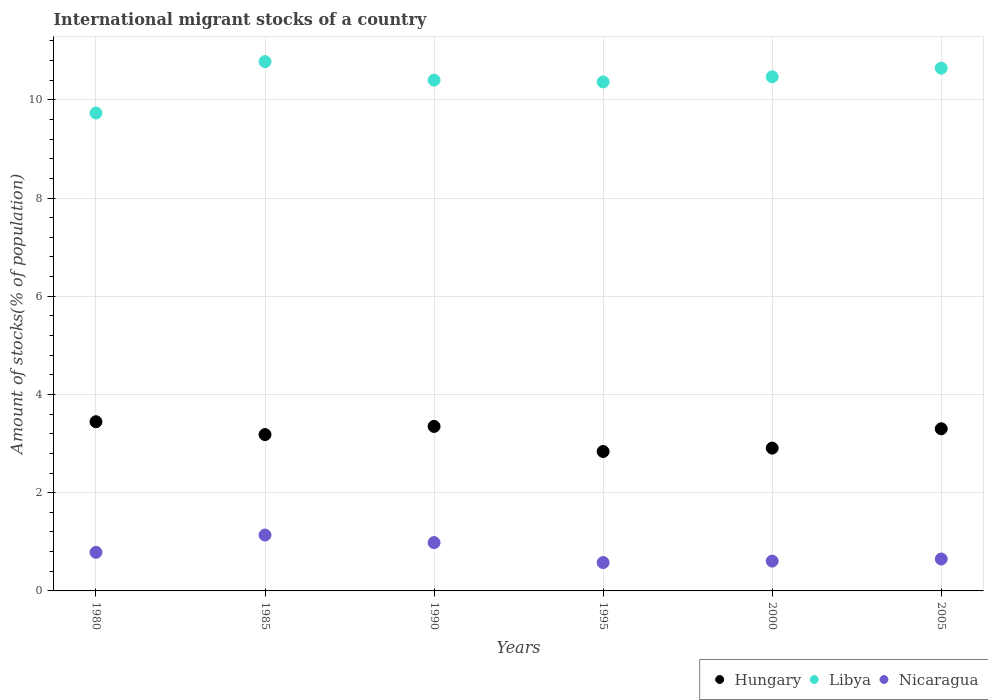How many different coloured dotlines are there?
Your answer should be very brief. 3. What is the amount of stocks in in Hungary in 1985?
Provide a succinct answer. 3.18. Across all years, what is the maximum amount of stocks in in Nicaragua?
Offer a very short reply. 1.14. Across all years, what is the minimum amount of stocks in in Nicaragua?
Your response must be concise. 0.58. In which year was the amount of stocks in in Hungary minimum?
Your answer should be compact. 1995. What is the total amount of stocks in in Libya in the graph?
Make the answer very short. 62.39. What is the difference between the amount of stocks in in Nicaragua in 1980 and that in 1990?
Your answer should be compact. -0.2. What is the difference between the amount of stocks in in Hungary in 1995 and the amount of stocks in in Libya in 2000?
Your answer should be compact. -7.63. What is the average amount of stocks in in Hungary per year?
Ensure brevity in your answer.  3.17. In the year 1990, what is the difference between the amount of stocks in in Libya and amount of stocks in in Nicaragua?
Provide a short and direct response. 9.42. What is the ratio of the amount of stocks in in Libya in 1980 to that in 1995?
Provide a succinct answer. 0.94. Is the amount of stocks in in Nicaragua in 1985 less than that in 2000?
Your answer should be very brief. No. What is the difference between the highest and the second highest amount of stocks in in Nicaragua?
Provide a short and direct response. 0.15. What is the difference between the highest and the lowest amount of stocks in in Libya?
Ensure brevity in your answer.  1.05. In how many years, is the amount of stocks in in Libya greater than the average amount of stocks in in Libya taken over all years?
Your answer should be compact. 4. Is the sum of the amount of stocks in in Hungary in 1990 and 1995 greater than the maximum amount of stocks in in Libya across all years?
Your answer should be very brief. No. Is the amount of stocks in in Nicaragua strictly greater than the amount of stocks in in Hungary over the years?
Provide a succinct answer. No. Is the amount of stocks in in Hungary strictly less than the amount of stocks in in Libya over the years?
Your answer should be compact. Yes. How many dotlines are there?
Make the answer very short. 3. How many years are there in the graph?
Your answer should be very brief. 6. What is the difference between two consecutive major ticks on the Y-axis?
Make the answer very short. 2. Are the values on the major ticks of Y-axis written in scientific E-notation?
Your answer should be compact. No. Does the graph contain grids?
Ensure brevity in your answer.  Yes. Where does the legend appear in the graph?
Your response must be concise. Bottom right. How are the legend labels stacked?
Offer a very short reply. Horizontal. What is the title of the graph?
Give a very brief answer. International migrant stocks of a country. Does "Brazil" appear as one of the legend labels in the graph?
Your answer should be very brief. No. What is the label or title of the Y-axis?
Your response must be concise. Amount of stocks(% of population). What is the Amount of stocks(% of population) of Hungary in 1980?
Give a very brief answer. 3.45. What is the Amount of stocks(% of population) of Libya in 1980?
Your response must be concise. 9.73. What is the Amount of stocks(% of population) in Nicaragua in 1980?
Provide a succinct answer. 0.79. What is the Amount of stocks(% of population) of Hungary in 1985?
Your answer should be very brief. 3.18. What is the Amount of stocks(% of population) of Libya in 1985?
Offer a very short reply. 10.78. What is the Amount of stocks(% of population) in Nicaragua in 1985?
Offer a terse response. 1.14. What is the Amount of stocks(% of population) of Hungary in 1990?
Keep it short and to the point. 3.35. What is the Amount of stocks(% of population) of Libya in 1990?
Offer a very short reply. 10.4. What is the Amount of stocks(% of population) in Nicaragua in 1990?
Your answer should be compact. 0.98. What is the Amount of stocks(% of population) in Hungary in 1995?
Give a very brief answer. 2.84. What is the Amount of stocks(% of population) of Libya in 1995?
Keep it short and to the point. 10.36. What is the Amount of stocks(% of population) of Nicaragua in 1995?
Your response must be concise. 0.58. What is the Amount of stocks(% of population) of Hungary in 2000?
Ensure brevity in your answer.  2.91. What is the Amount of stocks(% of population) in Libya in 2000?
Give a very brief answer. 10.47. What is the Amount of stocks(% of population) of Nicaragua in 2000?
Offer a very short reply. 0.61. What is the Amount of stocks(% of population) in Hungary in 2005?
Offer a terse response. 3.3. What is the Amount of stocks(% of population) of Libya in 2005?
Make the answer very short. 10.64. What is the Amount of stocks(% of population) of Nicaragua in 2005?
Provide a succinct answer. 0.65. Across all years, what is the maximum Amount of stocks(% of population) of Hungary?
Provide a succinct answer. 3.45. Across all years, what is the maximum Amount of stocks(% of population) of Libya?
Give a very brief answer. 10.78. Across all years, what is the maximum Amount of stocks(% of population) in Nicaragua?
Your response must be concise. 1.14. Across all years, what is the minimum Amount of stocks(% of population) of Hungary?
Your answer should be compact. 2.84. Across all years, what is the minimum Amount of stocks(% of population) of Libya?
Give a very brief answer. 9.73. Across all years, what is the minimum Amount of stocks(% of population) in Nicaragua?
Your response must be concise. 0.58. What is the total Amount of stocks(% of population) of Hungary in the graph?
Offer a very short reply. 19.03. What is the total Amount of stocks(% of population) of Libya in the graph?
Provide a succinct answer. 62.39. What is the total Amount of stocks(% of population) in Nicaragua in the graph?
Provide a short and direct response. 4.74. What is the difference between the Amount of stocks(% of population) of Hungary in 1980 and that in 1985?
Offer a terse response. 0.26. What is the difference between the Amount of stocks(% of population) of Libya in 1980 and that in 1985?
Offer a terse response. -1.05. What is the difference between the Amount of stocks(% of population) of Nicaragua in 1980 and that in 1985?
Make the answer very short. -0.35. What is the difference between the Amount of stocks(% of population) in Hungary in 1980 and that in 1990?
Your answer should be compact. 0.1. What is the difference between the Amount of stocks(% of population) in Libya in 1980 and that in 1990?
Your answer should be very brief. -0.67. What is the difference between the Amount of stocks(% of population) in Nicaragua in 1980 and that in 1990?
Keep it short and to the point. -0.2. What is the difference between the Amount of stocks(% of population) in Hungary in 1980 and that in 1995?
Keep it short and to the point. 0.61. What is the difference between the Amount of stocks(% of population) in Libya in 1980 and that in 1995?
Keep it short and to the point. -0.63. What is the difference between the Amount of stocks(% of population) of Nicaragua in 1980 and that in 1995?
Provide a short and direct response. 0.21. What is the difference between the Amount of stocks(% of population) in Hungary in 1980 and that in 2000?
Provide a succinct answer. 0.54. What is the difference between the Amount of stocks(% of population) in Libya in 1980 and that in 2000?
Give a very brief answer. -0.74. What is the difference between the Amount of stocks(% of population) in Nicaragua in 1980 and that in 2000?
Give a very brief answer. 0.18. What is the difference between the Amount of stocks(% of population) of Hungary in 1980 and that in 2005?
Offer a terse response. 0.14. What is the difference between the Amount of stocks(% of population) in Libya in 1980 and that in 2005?
Your answer should be compact. -0.91. What is the difference between the Amount of stocks(% of population) in Nicaragua in 1980 and that in 2005?
Your answer should be very brief. 0.14. What is the difference between the Amount of stocks(% of population) in Hungary in 1985 and that in 1990?
Provide a short and direct response. -0.17. What is the difference between the Amount of stocks(% of population) of Libya in 1985 and that in 1990?
Your answer should be compact. 0.38. What is the difference between the Amount of stocks(% of population) in Nicaragua in 1985 and that in 1990?
Your answer should be compact. 0.15. What is the difference between the Amount of stocks(% of population) in Hungary in 1985 and that in 1995?
Make the answer very short. 0.34. What is the difference between the Amount of stocks(% of population) in Libya in 1985 and that in 1995?
Ensure brevity in your answer.  0.41. What is the difference between the Amount of stocks(% of population) of Nicaragua in 1985 and that in 1995?
Your answer should be very brief. 0.56. What is the difference between the Amount of stocks(% of population) of Hungary in 1985 and that in 2000?
Provide a short and direct response. 0.28. What is the difference between the Amount of stocks(% of population) in Libya in 1985 and that in 2000?
Give a very brief answer. 0.31. What is the difference between the Amount of stocks(% of population) in Nicaragua in 1985 and that in 2000?
Provide a succinct answer. 0.53. What is the difference between the Amount of stocks(% of population) of Hungary in 1985 and that in 2005?
Provide a short and direct response. -0.12. What is the difference between the Amount of stocks(% of population) of Libya in 1985 and that in 2005?
Ensure brevity in your answer.  0.13. What is the difference between the Amount of stocks(% of population) in Nicaragua in 1985 and that in 2005?
Your response must be concise. 0.49. What is the difference between the Amount of stocks(% of population) in Hungary in 1990 and that in 1995?
Give a very brief answer. 0.51. What is the difference between the Amount of stocks(% of population) of Libya in 1990 and that in 1995?
Offer a very short reply. 0.04. What is the difference between the Amount of stocks(% of population) of Nicaragua in 1990 and that in 1995?
Offer a terse response. 0.41. What is the difference between the Amount of stocks(% of population) of Hungary in 1990 and that in 2000?
Provide a short and direct response. 0.44. What is the difference between the Amount of stocks(% of population) of Libya in 1990 and that in 2000?
Your answer should be compact. -0.07. What is the difference between the Amount of stocks(% of population) of Nicaragua in 1990 and that in 2000?
Make the answer very short. 0.38. What is the difference between the Amount of stocks(% of population) in Hungary in 1990 and that in 2005?
Your response must be concise. 0.05. What is the difference between the Amount of stocks(% of population) of Libya in 1990 and that in 2005?
Provide a succinct answer. -0.24. What is the difference between the Amount of stocks(% of population) in Nicaragua in 1990 and that in 2005?
Offer a very short reply. 0.33. What is the difference between the Amount of stocks(% of population) of Hungary in 1995 and that in 2000?
Ensure brevity in your answer.  -0.07. What is the difference between the Amount of stocks(% of population) in Libya in 1995 and that in 2000?
Offer a terse response. -0.1. What is the difference between the Amount of stocks(% of population) in Nicaragua in 1995 and that in 2000?
Your answer should be compact. -0.03. What is the difference between the Amount of stocks(% of population) of Hungary in 1995 and that in 2005?
Your response must be concise. -0.46. What is the difference between the Amount of stocks(% of population) in Libya in 1995 and that in 2005?
Offer a very short reply. -0.28. What is the difference between the Amount of stocks(% of population) in Nicaragua in 1995 and that in 2005?
Your answer should be compact. -0.07. What is the difference between the Amount of stocks(% of population) in Hungary in 2000 and that in 2005?
Your answer should be compact. -0.39. What is the difference between the Amount of stocks(% of population) in Libya in 2000 and that in 2005?
Your response must be concise. -0.18. What is the difference between the Amount of stocks(% of population) in Nicaragua in 2000 and that in 2005?
Make the answer very short. -0.04. What is the difference between the Amount of stocks(% of population) in Hungary in 1980 and the Amount of stocks(% of population) in Libya in 1985?
Your response must be concise. -7.33. What is the difference between the Amount of stocks(% of population) in Hungary in 1980 and the Amount of stocks(% of population) in Nicaragua in 1985?
Provide a succinct answer. 2.31. What is the difference between the Amount of stocks(% of population) of Libya in 1980 and the Amount of stocks(% of population) of Nicaragua in 1985?
Your answer should be compact. 8.59. What is the difference between the Amount of stocks(% of population) of Hungary in 1980 and the Amount of stocks(% of population) of Libya in 1990?
Ensure brevity in your answer.  -6.96. What is the difference between the Amount of stocks(% of population) in Hungary in 1980 and the Amount of stocks(% of population) in Nicaragua in 1990?
Your answer should be very brief. 2.46. What is the difference between the Amount of stocks(% of population) of Libya in 1980 and the Amount of stocks(% of population) of Nicaragua in 1990?
Ensure brevity in your answer.  8.75. What is the difference between the Amount of stocks(% of population) in Hungary in 1980 and the Amount of stocks(% of population) in Libya in 1995?
Ensure brevity in your answer.  -6.92. What is the difference between the Amount of stocks(% of population) in Hungary in 1980 and the Amount of stocks(% of population) in Nicaragua in 1995?
Keep it short and to the point. 2.87. What is the difference between the Amount of stocks(% of population) of Libya in 1980 and the Amount of stocks(% of population) of Nicaragua in 1995?
Make the answer very short. 9.15. What is the difference between the Amount of stocks(% of population) in Hungary in 1980 and the Amount of stocks(% of population) in Libya in 2000?
Provide a succinct answer. -7.02. What is the difference between the Amount of stocks(% of population) of Hungary in 1980 and the Amount of stocks(% of population) of Nicaragua in 2000?
Your response must be concise. 2.84. What is the difference between the Amount of stocks(% of population) in Libya in 1980 and the Amount of stocks(% of population) in Nicaragua in 2000?
Provide a short and direct response. 9.12. What is the difference between the Amount of stocks(% of population) in Hungary in 1980 and the Amount of stocks(% of population) in Libya in 2005?
Make the answer very short. -7.2. What is the difference between the Amount of stocks(% of population) in Hungary in 1980 and the Amount of stocks(% of population) in Nicaragua in 2005?
Keep it short and to the point. 2.8. What is the difference between the Amount of stocks(% of population) of Libya in 1980 and the Amount of stocks(% of population) of Nicaragua in 2005?
Provide a succinct answer. 9.08. What is the difference between the Amount of stocks(% of population) in Hungary in 1985 and the Amount of stocks(% of population) in Libya in 1990?
Provide a succinct answer. -7.22. What is the difference between the Amount of stocks(% of population) in Hungary in 1985 and the Amount of stocks(% of population) in Nicaragua in 1990?
Offer a terse response. 2.2. What is the difference between the Amount of stocks(% of population) in Libya in 1985 and the Amount of stocks(% of population) in Nicaragua in 1990?
Provide a succinct answer. 9.79. What is the difference between the Amount of stocks(% of population) of Hungary in 1985 and the Amount of stocks(% of population) of Libya in 1995?
Offer a very short reply. -7.18. What is the difference between the Amount of stocks(% of population) of Hungary in 1985 and the Amount of stocks(% of population) of Nicaragua in 1995?
Provide a short and direct response. 2.61. What is the difference between the Amount of stocks(% of population) of Libya in 1985 and the Amount of stocks(% of population) of Nicaragua in 1995?
Offer a terse response. 10.2. What is the difference between the Amount of stocks(% of population) of Hungary in 1985 and the Amount of stocks(% of population) of Libya in 2000?
Ensure brevity in your answer.  -7.29. What is the difference between the Amount of stocks(% of population) in Hungary in 1985 and the Amount of stocks(% of population) in Nicaragua in 2000?
Your answer should be very brief. 2.58. What is the difference between the Amount of stocks(% of population) in Libya in 1985 and the Amount of stocks(% of population) in Nicaragua in 2000?
Ensure brevity in your answer.  10.17. What is the difference between the Amount of stocks(% of population) of Hungary in 1985 and the Amount of stocks(% of population) of Libya in 2005?
Your answer should be compact. -7.46. What is the difference between the Amount of stocks(% of population) in Hungary in 1985 and the Amount of stocks(% of population) in Nicaragua in 2005?
Keep it short and to the point. 2.53. What is the difference between the Amount of stocks(% of population) in Libya in 1985 and the Amount of stocks(% of population) in Nicaragua in 2005?
Ensure brevity in your answer.  10.13. What is the difference between the Amount of stocks(% of population) in Hungary in 1990 and the Amount of stocks(% of population) in Libya in 1995?
Provide a succinct answer. -7.01. What is the difference between the Amount of stocks(% of population) of Hungary in 1990 and the Amount of stocks(% of population) of Nicaragua in 1995?
Your answer should be very brief. 2.77. What is the difference between the Amount of stocks(% of population) of Libya in 1990 and the Amount of stocks(% of population) of Nicaragua in 1995?
Give a very brief answer. 9.82. What is the difference between the Amount of stocks(% of population) in Hungary in 1990 and the Amount of stocks(% of population) in Libya in 2000?
Your answer should be compact. -7.12. What is the difference between the Amount of stocks(% of population) in Hungary in 1990 and the Amount of stocks(% of population) in Nicaragua in 2000?
Ensure brevity in your answer.  2.74. What is the difference between the Amount of stocks(% of population) of Libya in 1990 and the Amount of stocks(% of population) of Nicaragua in 2000?
Keep it short and to the point. 9.79. What is the difference between the Amount of stocks(% of population) of Hungary in 1990 and the Amount of stocks(% of population) of Libya in 2005?
Offer a terse response. -7.29. What is the difference between the Amount of stocks(% of population) of Hungary in 1990 and the Amount of stocks(% of population) of Nicaragua in 2005?
Offer a very short reply. 2.7. What is the difference between the Amount of stocks(% of population) in Libya in 1990 and the Amount of stocks(% of population) in Nicaragua in 2005?
Provide a succinct answer. 9.75. What is the difference between the Amount of stocks(% of population) in Hungary in 1995 and the Amount of stocks(% of population) in Libya in 2000?
Provide a succinct answer. -7.63. What is the difference between the Amount of stocks(% of population) of Hungary in 1995 and the Amount of stocks(% of population) of Nicaragua in 2000?
Give a very brief answer. 2.23. What is the difference between the Amount of stocks(% of population) in Libya in 1995 and the Amount of stocks(% of population) in Nicaragua in 2000?
Provide a succinct answer. 9.76. What is the difference between the Amount of stocks(% of population) of Hungary in 1995 and the Amount of stocks(% of population) of Libya in 2005?
Your response must be concise. -7.81. What is the difference between the Amount of stocks(% of population) in Hungary in 1995 and the Amount of stocks(% of population) in Nicaragua in 2005?
Provide a short and direct response. 2.19. What is the difference between the Amount of stocks(% of population) of Libya in 1995 and the Amount of stocks(% of population) of Nicaragua in 2005?
Your response must be concise. 9.71. What is the difference between the Amount of stocks(% of population) of Hungary in 2000 and the Amount of stocks(% of population) of Libya in 2005?
Offer a very short reply. -7.74. What is the difference between the Amount of stocks(% of population) of Hungary in 2000 and the Amount of stocks(% of population) of Nicaragua in 2005?
Offer a terse response. 2.26. What is the difference between the Amount of stocks(% of population) of Libya in 2000 and the Amount of stocks(% of population) of Nicaragua in 2005?
Your answer should be compact. 9.82. What is the average Amount of stocks(% of population) of Hungary per year?
Give a very brief answer. 3.17. What is the average Amount of stocks(% of population) of Libya per year?
Keep it short and to the point. 10.4. What is the average Amount of stocks(% of population) of Nicaragua per year?
Your response must be concise. 0.79. In the year 1980, what is the difference between the Amount of stocks(% of population) of Hungary and Amount of stocks(% of population) of Libya?
Give a very brief answer. -6.29. In the year 1980, what is the difference between the Amount of stocks(% of population) of Hungary and Amount of stocks(% of population) of Nicaragua?
Make the answer very short. 2.66. In the year 1980, what is the difference between the Amount of stocks(% of population) in Libya and Amount of stocks(% of population) in Nicaragua?
Provide a succinct answer. 8.95. In the year 1985, what is the difference between the Amount of stocks(% of population) of Hungary and Amount of stocks(% of population) of Libya?
Your response must be concise. -7.59. In the year 1985, what is the difference between the Amount of stocks(% of population) in Hungary and Amount of stocks(% of population) in Nicaragua?
Provide a short and direct response. 2.05. In the year 1985, what is the difference between the Amount of stocks(% of population) in Libya and Amount of stocks(% of population) in Nicaragua?
Your answer should be very brief. 9.64. In the year 1990, what is the difference between the Amount of stocks(% of population) of Hungary and Amount of stocks(% of population) of Libya?
Ensure brevity in your answer.  -7.05. In the year 1990, what is the difference between the Amount of stocks(% of population) in Hungary and Amount of stocks(% of population) in Nicaragua?
Your answer should be compact. 2.37. In the year 1990, what is the difference between the Amount of stocks(% of population) of Libya and Amount of stocks(% of population) of Nicaragua?
Keep it short and to the point. 9.42. In the year 1995, what is the difference between the Amount of stocks(% of population) of Hungary and Amount of stocks(% of population) of Libya?
Your answer should be compact. -7.53. In the year 1995, what is the difference between the Amount of stocks(% of population) in Hungary and Amount of stocks(% of population) in Nicaragua?
Ensure brevity in your answer.  2.26. In the year 1995, what is the difference between the Amount of stocks(% of population) of Libya and Amount of stocks(% of population) of Nicaragua?
Your answer should be very brief. 9.79. In the year 2000, what is the difference between the Amount of stocks(% of population) of Hungary and Amount of stocks(% of population) of Libya?
Your answer should be very brief. -7.56. In the year 2000, what is the difference between the Amount of stocks(% of population) of Hungary and Amount of stocks(% of population) of Nicaragua?
Make the answer very short. 2.3. In the year 2000, what is the difference between the Amount of stocks(% of population) of Libya and Amount of stocks(% of population) of Nicaragua?
Ensure brevity in your answer.  9.86. In the year 2005, what is the difference between the Amount of stocks(% of population) in Hungary and Amount of stocks(% of population) in Libya?
Keep it short and to the point. -7.34. In the year 2005, what is the difference between the Amount of stocks(% of population) in Hungary and Amount of stocks(% of population) in Nicaragua?
Offer a terse response. 2.65. In the year 2005, what is the difference between the Amount of stocks(% of population) of Libya and Amount of stocks(% of population) of Nicaragua?
Ensure brevity in your answer.  9.99. What is the ratio of the Amount of stocks(% of population) in Hungary in 1980 to that in 1985?
Provide a succinct answer. 1.08. What is the ratio of the Amount of stocks(% of population) of Libya in 1980 to that in 1985?
Make the answer very short. 0.9. What is the ratio of the Amount of stocks(% of population) in Nicaragua in 1980 to that in 1985?
Offer a terse response. 0.69. What is the ratio of the Amount of stocks(% of population) of Hungary in 1980 to that in 1990?
Your answer should be compact. 1.03. What is the ratio of the Amount of stocks(% of population) of Libya in 1980 to that in 1990?
Give a very brief answer. 0.94. What is the ratio of the Amount of stocks(% of population) in Nicaragua in 1980 to that in 1990?
Your response must be concise. 0.8. What is the ratio of the Amount of stocks(% of population) of Hungary in 1980 to that in 1995?
Give a very brief answer. 1.21. What is the ratio of the Amount of stocks(% of population) of Libya in 1980 to that in 1995?
Offer a terse response. 0.94. What is the ratio of the Amount of stocks(% of population) of Nicaragua in 1980 to that in 1995?
Your answer should be very brief. 1.36. What is the ratio of the Amount of stocks(% of population) in Hungary in 1980 to that in 2000?
Make the answer very short. 1.18. What is the ratio of the Amount of stocks(% of population) in Libya in 1980 to that in 2000?
Give a very brief answer. 0.93. What is the ratio of the Amount of stocks(% of population) in Nicaragua in 1980 to that in 2000?
Give a very brief answer. 1.29. What is the ratio of the Amount of stocks(% of population) of Hungary in 1980 to that in 2005?
Keep it short and to the point. 1.04. What is the ratio of the Amount of stocks(% of population) of Libya in 1980 to that in 2005?
Your answer should be very brief. 0.91. What is the ratio of the Amount of stocks(% of population) in Nicaragua in 1980 to that in 2005?
Provide a succinct answer. 1.21. What is the ratio of the Amount of stocks(% of population) in Hungary in 1985 to that in 1990?
Give a very brief answer. 0.95. What is the ratio of the Amount of stocks(% of population) in Libya in 1985 to that in 1990?
Offer a very short reply. 1.04. What is the ratio of the Amount of stocks(% of population) of Nicaragua in 1985 to that in 1990?
Offer a very short reply. 1.16. What is the ratio of the Amount of stocks(% of population) in Hungary in 1985 to that in 1995?
Offer a very short reply. 1.12. What is the ratio of the Amount of stocks(% of population) of Libya in 1985 to that in 1995?
Your answer should be very brief. 1.04. What is the ratio of the Amount of stocks(% of population) of Nicaragua in 1985 to that in 1995?
Make the answer very short. 1.97. What is the ratio of the Amount of stocks(% of population) of Hungary in 1985 to that in 2000?
Keep it short and to the point. 1.09. What is the ratio of the Amount of stocks(% of population) of Libya in 1985 to that in 2000?
Keep it short and to the point. 1.03. What is the ratio of the Amount of stocks(% of population) of Nicaragua in 1985 to that in 2000?
Your answer should be compact. 1.87. What is the ratio of the Amount of stocks(% of population) of Hungary in 1985 to that in 2005?
Keep it short and to the point. 0.96. What is the ratio of the Amount of stocks(% of population) in Libya in 1985 to that in 2005?
Offer a terse response. 1.01. What is the ratio of the Amount of stocks(% of population) in Nicaragua in 1985 to that in 2005?
Give a very brief answer. 1.75. What is the ratio of the Amount of stocks(% of population) of Hungary in 1990 to that in 1995?
Give a very brief answer. 1.18. What is the ratio of the Amount of stocks(% of population) in Libya in 1990 to that in 1995?
Your answer should be compact. 1. What is the ratio of the Amount of stocks(% of population) in Nicaragua in 1990 to that in 1995?
Keep it short and to the point. 1.7. What is the ratio of the Amount of stocks(% of population) in Hungary in 1990 to that in 2000?
Provide a succinct answer. 1.15. What is the ratio of the Amount of stocks(% of population) of Libya in 1990 to that in 2000?
Ensure brevity in your answer.  0.99. What is the ratio of the Amount of stocks(% of population) of Nicaragua in 1990 to that in 2000?
Your answer should be compact. 1.62. What is the ratio of the Amount of stocks(% of population) in Hungary in 1990 to that in 2005?
Ensure brevity in your answer.  1.01. What is the ratio of the Amount of stocks(% of population) of Libya in 1990 to that in 2005?
Provide a succinct answer. 0.98. What is the ratio of the Amount of stocks(% of population) of Nicaragua in 1990 to that in 2005?
Provide a succinct answer. 1.51. What is the ratio of the Amount of stocks(% of population) in Hungary in 1995 to that in 2000?
Give a very brief answer. 0.98. What is the ratio of the Amount of stocks(% of population) in Libya in 1995 to that in 2000?
Make the answer very short. 0.99. What is the ratio of the Amount of stocks(% of population) in Nicaragua in 1995 to that in 2000?
Your answer should be very brief. 0.95. What is the ratio of the Amount of stocks(% of population) of Hungary in 1995 to that in 2005?
Offer a terse response. 0.86. What is the ratio of the Amount of stocks(% of population) in Libya in 1995 to that in 2005?
Ensure brevity in your answer.  0.97. What is the ratio of the Amount of stocks(% of population) in Nicaragua in 1995 to that in 2005?
Make the answer very short. 0.89. What is the ratio of the Amount of stocks(% of population) of Hungary in 2000 to that in 2005?
Your answer should be compact. 0.88. What is the ratio of the Amount of stocks(% of population) in Libya in 2000 to that in 2005?
Ensure brevity in your answer.  0.98. What is the ratio of the Amount of stocks(% of population) of Nicaragua in 2000 to that in 2005?
Keep it short and to the point. 0.94. What is the difference between the highest and the second highest Amount of stocks(% of population) of Hungary?
Your answer should be very brief. 0.1. What is the difference between the highest and the second highest Amount of stocks(% of population) of Libya?
Make the answer very short. 0.13. What is the difference between the highest and the second highest Amount of stocks(% of population) in Nicaragua?
Offer a terse response. 0.15. What is the difference between the highest and the lowest Amount of stocks(% of population) in Hungary?
Your answer should be compact. 0.61. What is the difference between the highest and the lowest Amount of stocks(% of population) in Libya?
Offer a very short reply. 1.05. What is the difference between the highest and the lowest Amount of stocks(% of population) of Nicaragua?
Give a very brief answer. 0.56. 